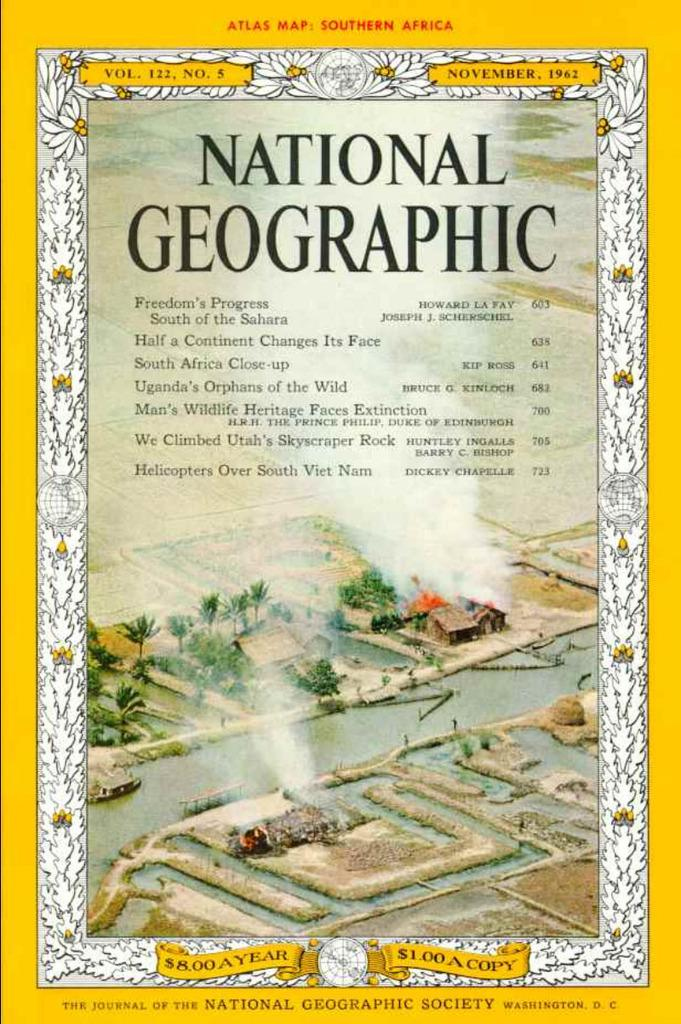<image>
Provide a brief description of the given image. The cover of a National Geographic magazine shows it is from 1962 